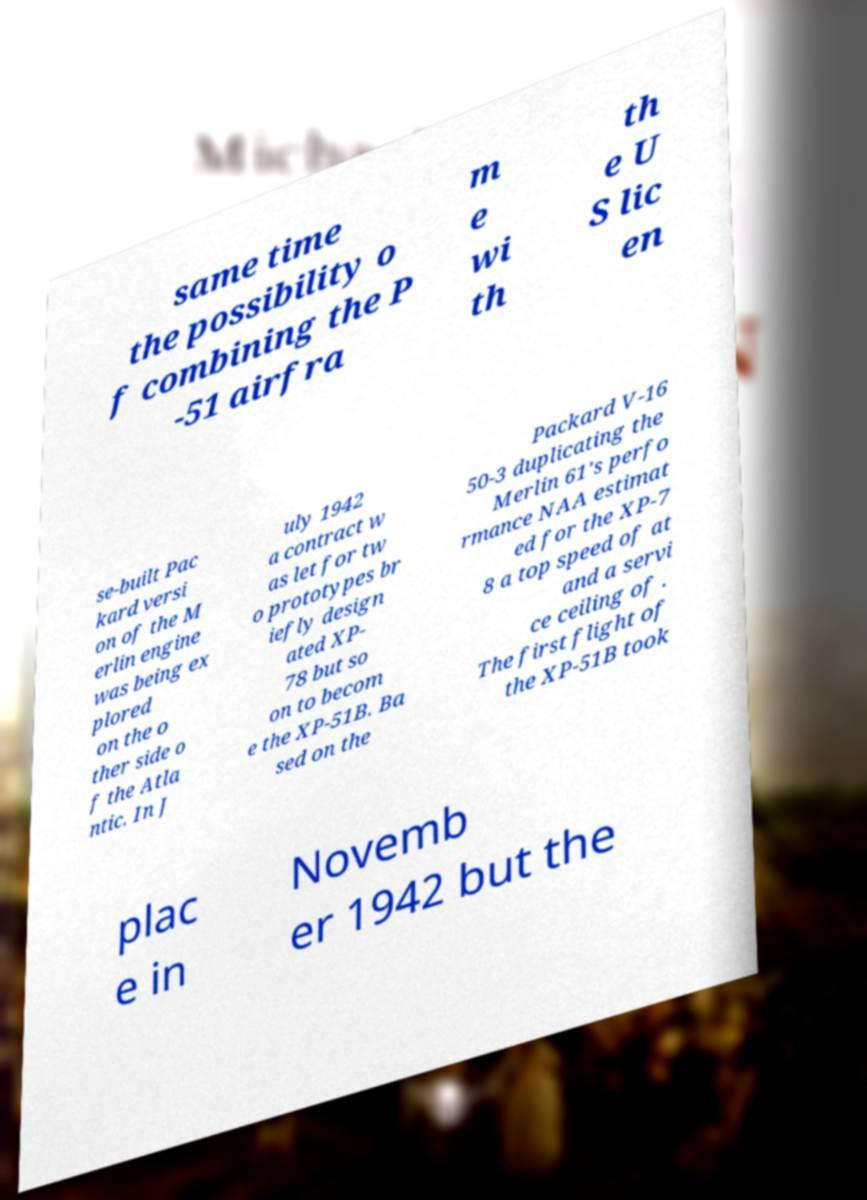What messages or text are displayed in this image? I need them in a readable, typed format. same time the possibility o f combining the P -51 airfra m e wi th th e U S lic en se-built Pac kard versi on of the M erlin engine was being ex plored on the o ther side o f the Atla ntic. In J uly 1942 a contract w as let for tw o prototypes br iefly design ated XP- 78 but so on to becom e the XP-51B. Ba sed on the Packard V-16 50-3 duplicating the Merlin 61's perfo rmance NAA estimat ed for the XP-7 8 a top speed of at and a servi ce ceiling of . The first flight of the XP-51B took plac e in Novemb er 1942 but the 